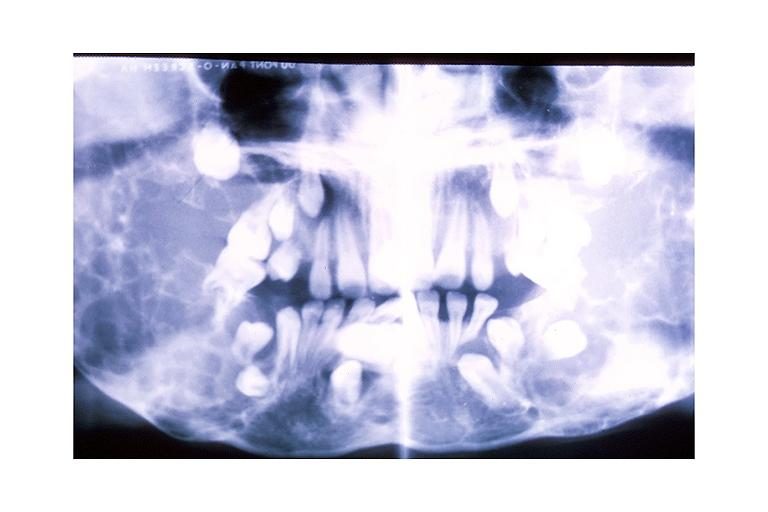what does this image show?
Answer the question using a single word or phrase. Cherubism 